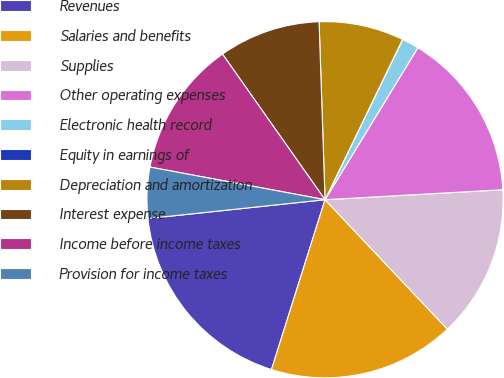Convert chart. <chart><loc_0><loc_0><loc_500><loc_500><pie_chart><fcel>Revenues<fcel>Salaries and benefits<fcel>Supplies<fcel>Other operating expenses<fcel>Electronic health record<fcel>Equity in earnings of<fcel>Depreciation and amortization<fcel>Interest expense<fcel>Income before income taxes<fcel>Provision for income taxes<nl><fcel>18.45%<fcel>16.91%<fcel>13.84%<fcel>15.38%<fcel>1.55%<fcel>0.01%<fcel>7.7%<fcel>9.23%<fcel>12.3%<fcel>4.62%<nl></chart> 